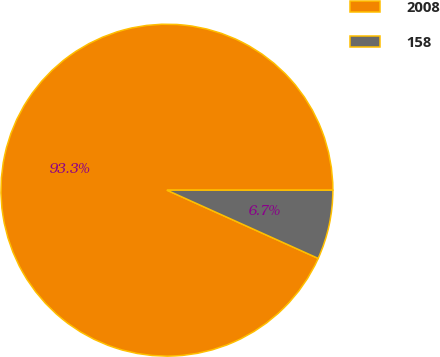Convert chart. <chart><loc_0><loc_0><loc_500><loc_500><pie_chart><fcel>2008<fcel>158<nl><fcel>93.26%<fcel>6.74%<nl></chart> 